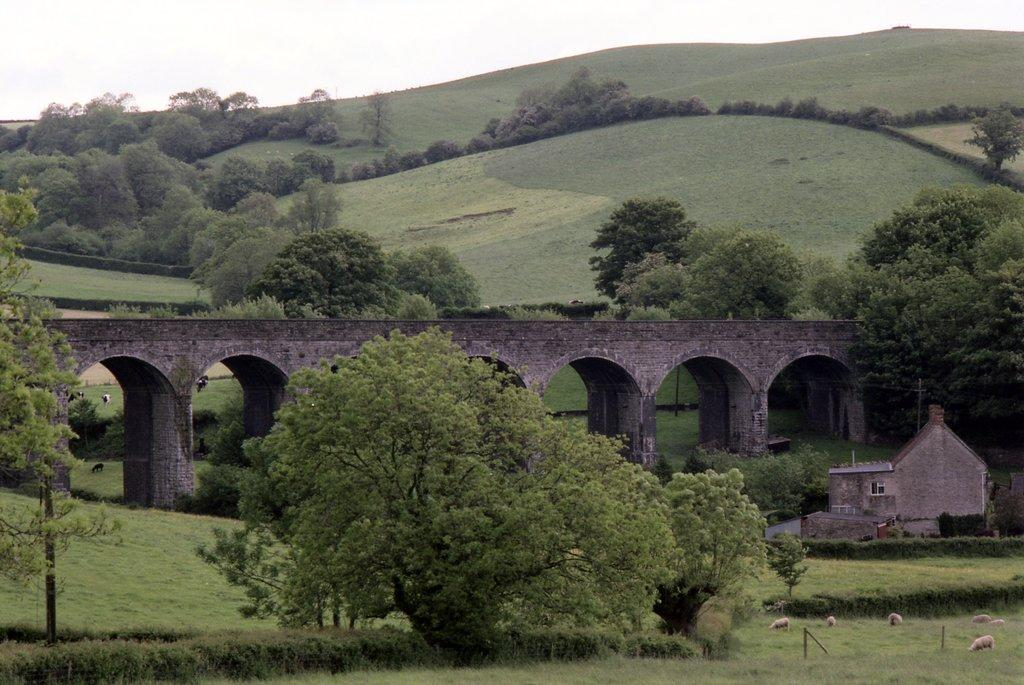What type of vegetation is present in the image? There are trees in the image. What man-made structure can be seen in the image? There is a bridge in the image. What type of building is visible in the image? There is a house in the image. What type of animals are on the ground in the image? There are animals on the ground in the image. What vertical structures are present in the image? There are poles in the image. What type of ground cover is present in the image? There is grass in the image. What is visible in the background of the image? The sky is visible in the background of the image. How many pizzas are being held by the animals in the image? There are no pizzas present in the image. What type of ray is swimming in the grass in the image? There is no ray present in the image, and rays do not swim in grass. 